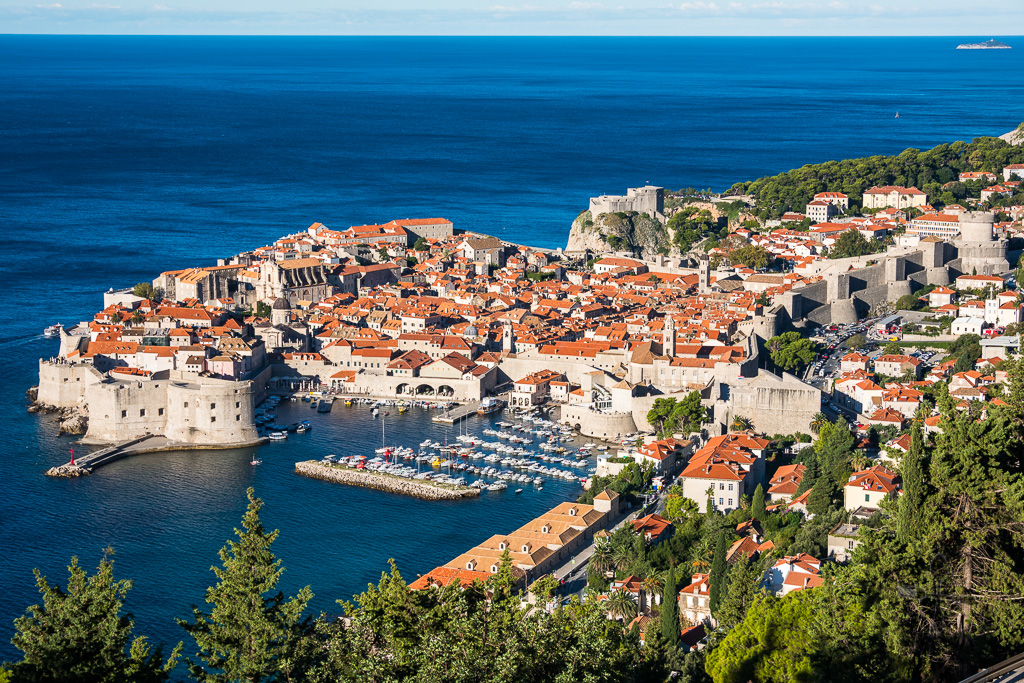Imagine the city walls coming to life and telling their story. What would they say? If the city walls of Dubrovnik could speak, they would recount tales of resilience and grandeur. 'We have stood firm against time and turmoil,' they might begin. 'We have seen merchants prosper, scholars thrive, and artists craft their masterpieces within our embrace. Through the centuries, we have protected the heart of Dubrovnik, from the terrors of sieges to the devastation of the great earthquake. We were the silent witnesses to the Republic’s golden age of trade, the whispers of diplomacy, and the clashing of swords during wars. Yet, our most poignant memories are of the unity and fortitude of the people who have called us home. We are not just stone and mortar; we are the testament to the indomitable spirit of Dubrovnik.' 